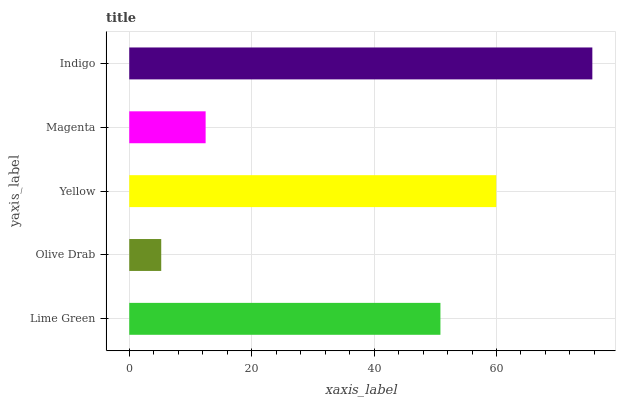Is Olive Drab the minimum?
Answer yes or no. Yes. Is Indigo the maximum?
Answer yes or no. Yes. Is Yellow the minimum?
Answer yes or no. No. Is Yellow the maximum?
Answer yes or no. No. Is Yellow greater than Olive Drab?
Answer yes or no. Yes. Is Olive Drab less than Yellow?
Answer yes or no. Yes. Is Olive Drab greater than Yellow?
Answer yes or no. No. Is Yellow less than Olive Drab?
Answer yes or no. No. Is Lime Green the high median?
Answer yes or no. Yes. Is Lime Green the low median?
Answer yes or no. Yes. Is Magenta the high median?
Answer yes or no. No. Is Magenta the low median?
Answer yes or no. No. 